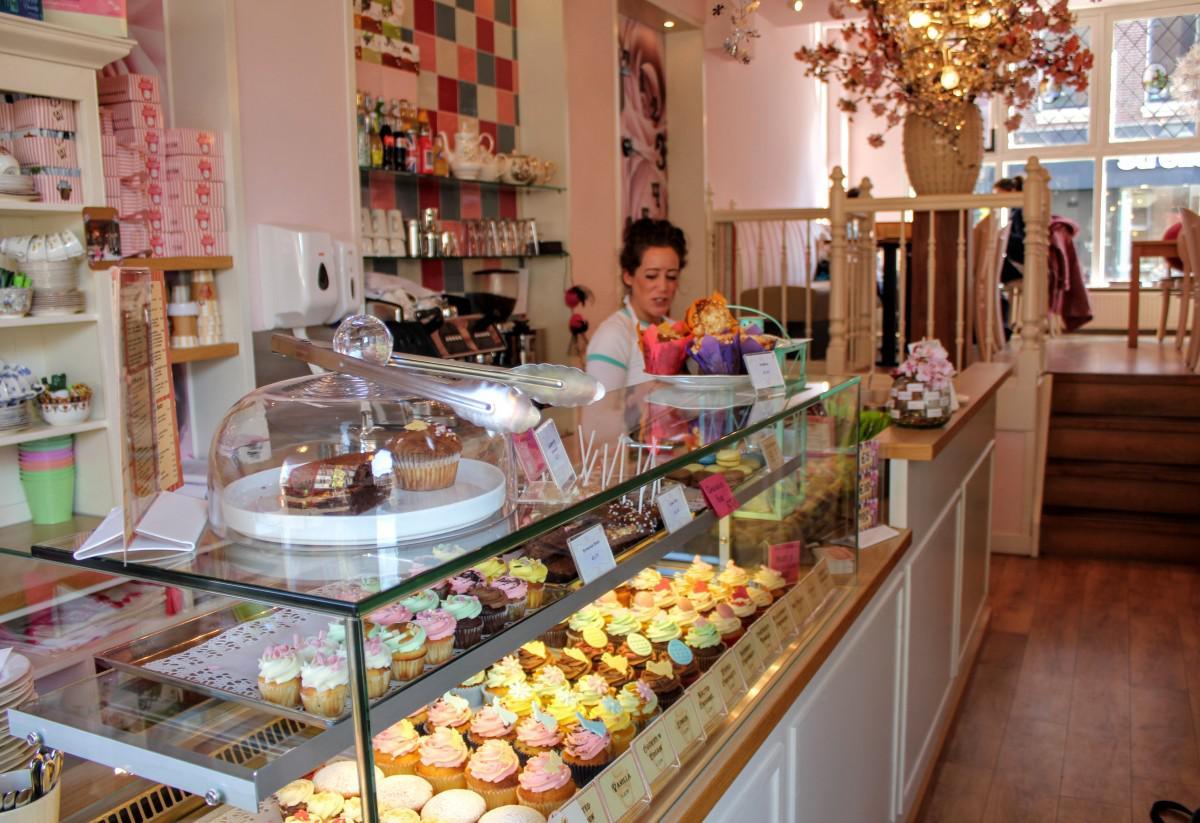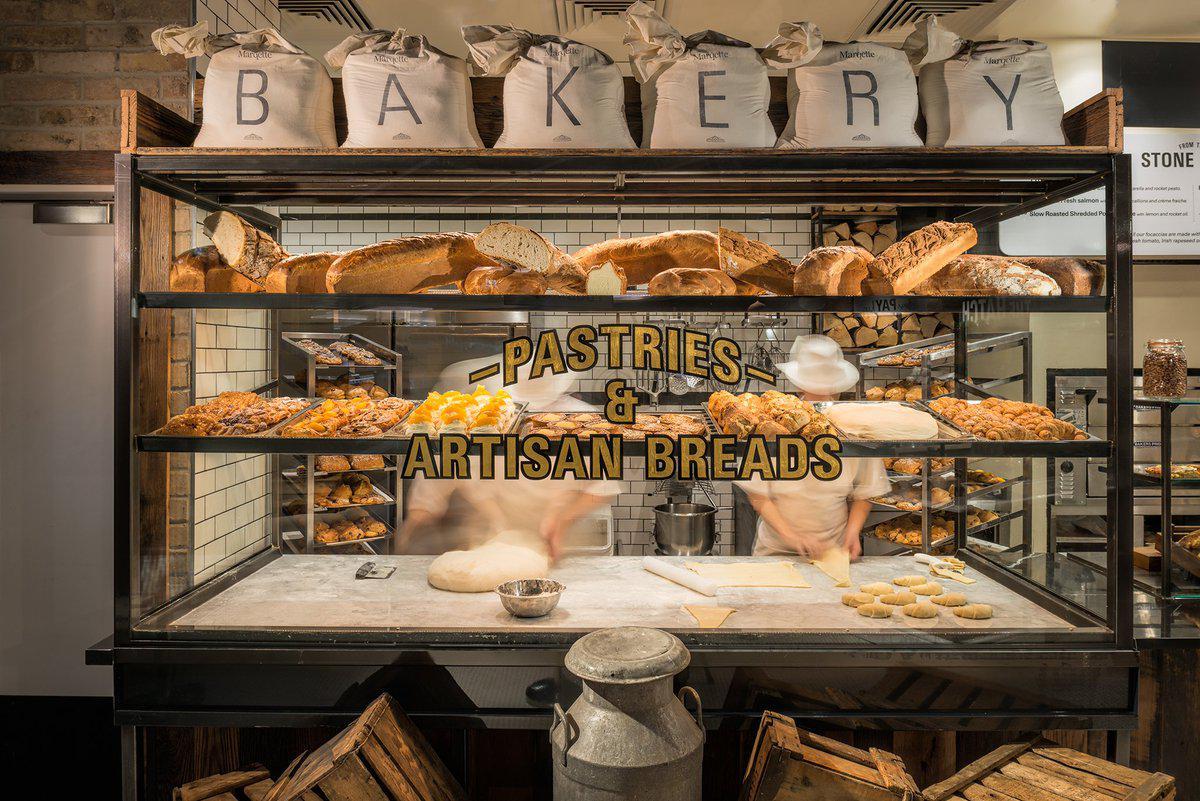The first image is the image on the left, the second image is the image on the right. Evaluate the accuracy of this statement regarding the images: "The only humans visible appear to be workers.". Is it true? Answer yes or no. Yes. The first image is the image on the left, the second image is the image on the right. For the images displayed, is the sentence "At least one woman with her hair up is working behind the counter of one bakery." factually correct? Answer yes or no. Yes. 